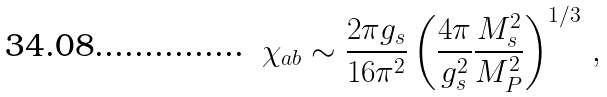<formula> <loc_0><loc_0><loc_500><loc_500>\chi _ { a b } \sim \frac { 2 \pi g _ { s } } { 1 6 \pi ^ { 2 } } \left ( \frac { 4 \pi } { g _ { s } ^ { 2 } } \frac { M _ { s } ^ { 2 } } { M _ { P } ^ { 2 } } \right ) ^ { 1 / 3 } \, ,</formula> 